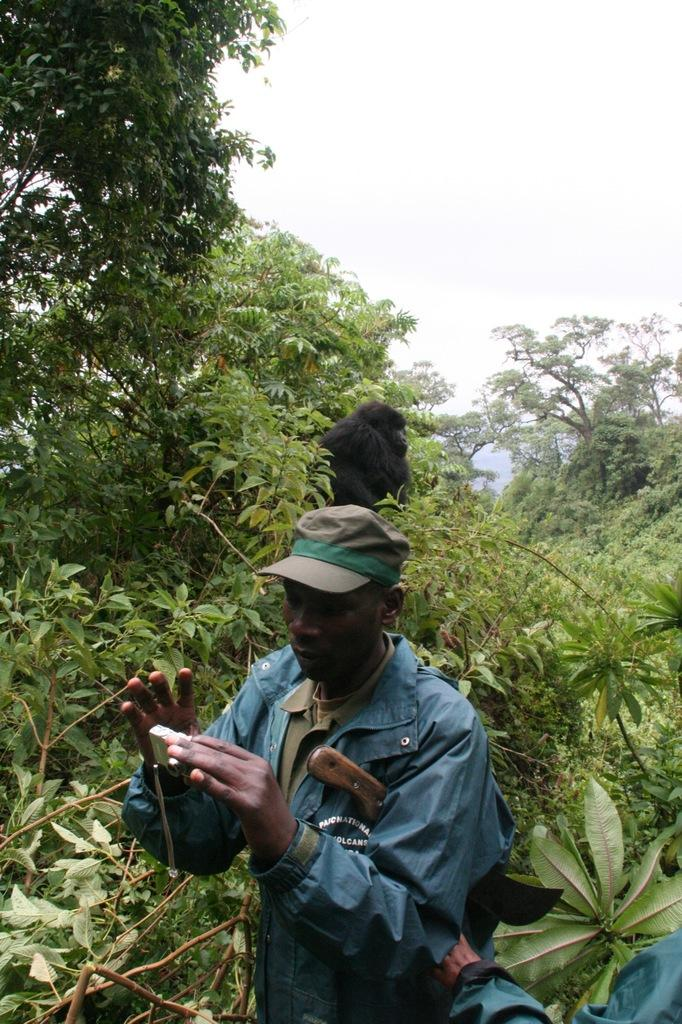Who or what is present in the image? There is a person and an animal in the image. What can be seen in the background of the image? There are trees and the sky visible in the background of the image. What type of wine is being served in the image? There is no wine present in the image; it features a person and an animal with trees and the sky in the background. 